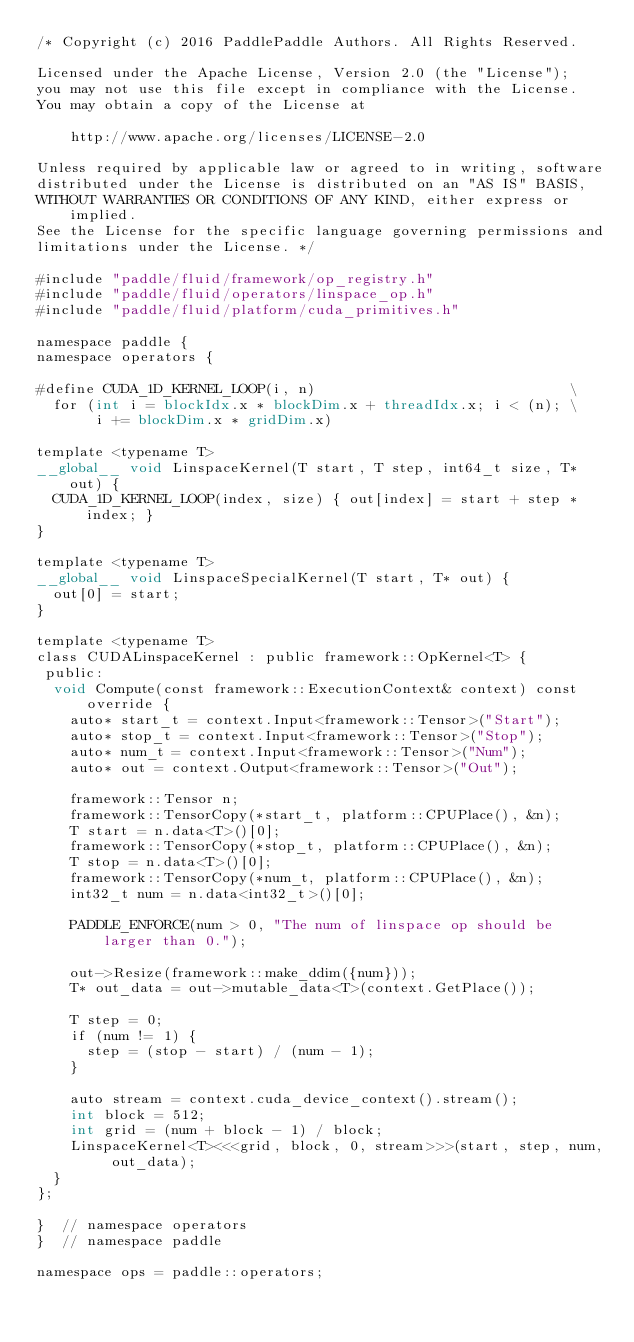<code> <loc_0><loc_0><loc_500><loc_500><_Cuda_>/* Copyright (c) 2016 PaddlePaddle Authors. All Rights Reserved.

Licensed under the Apache License, Version 2.0 (the "License");
you may not use this file except in compliance with the License.
You may obtain a copy of the License at

    http://www.apache.org/licenses/LICENSE-2.0

Unless required by applicable law or agreed to in writing, software
distributed under the License is distributed on an "AS IS" BASIS,
WITHOUT WARRANTIES OR CONDITIONS OF ANY KIND, either express or implied.
See the License for the specific language governing permissions and
limitations under the License. */

#include "paddle/fluid/framework/op_registry.h"
#include "paddle/fluid/operators/linspace_op.h"
#include "paddle/fluid/platform/cuda_primitives.h"

namespace paddle {
namespace operators {

#define CUDA_1D_KERNEL_LOOP(i, n)                              \
  for (int i = blockIdx.x * blockDim.x + threadIdx.x; i < (n); \
       i += blockDim.x * gridDim.x)

template <typename T>
__global__ void LinspaceKernel(T start, T step, int64_t size, T* out) {
  CUDA_1D_KERNEL_LOOP(index, size) { out[index] = start + step * index; }
}

template <typename T>
__global__ void LinspaceSpecialKernel(T start, T* out) {
  out[0] = start;
}

template <typename T>
class CUDALinspaceKernel : public framework::OpKernel<T> {
 public:
  void Compute(const framework::ExecutionContext& context) const override {
    auto* start_t = context.Input<framework::Tensor>("Start");
    auto* stop_t = context.Input<framework::Tensor>("Stop");
    auto* num_t = context.Input<framework::Tensor>("Num");
    auto* out = context.Output<framework::Tensor>("Out");

    framework::Tensor n;
    framework::TensorCopy(*start_t, platform::CPUPlace(), &n);
    T start = n.data<T>()[0];
    framework::TensorCopy(*stop_t, platform::CPUPlace(), &n);
    T stop = n.data<T>()[0];
    framework::TensorCopy(*num_t, platform::CPUPlace(), &n);
    int32_t num = n.data<int32_t>()[0];

    PADDLE_ENFORCE(num > 0, "The num of linspace op should be larger than 0.");

    out->Resize(framework::make_ddim({num}));
    T* out_data = out->mutable_data<T>(context.GetPlace());

    T step = 0;
    if (num != 1) {
      step = (stop - start) / (num - 1);
    }

    auto stream = context.cuda_device_context().stream();
    int block = 512;
    int grid = (num + block - 1) / block;
    LinspaceKernel<T><<<grid, block, 0, stream>>>(start, step, num, out_data);
  }
};

}  // namespace operators
}  // namespace paddle

namespace ops = paddle::operators;</code> 